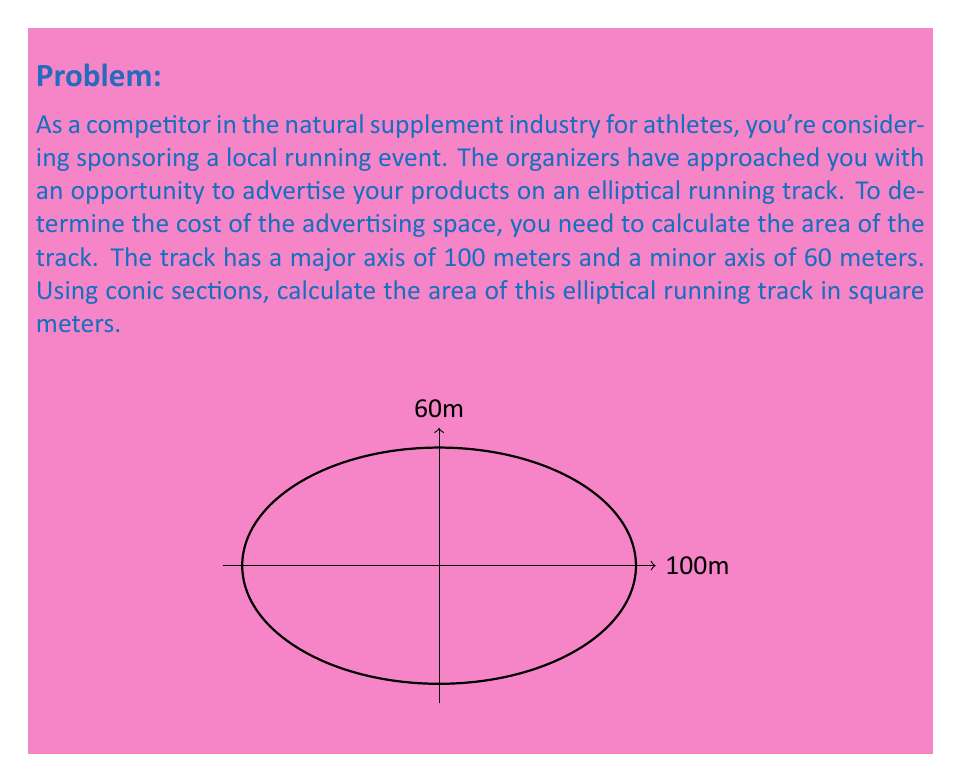Can you solve this math problem? To calculate the area of an elliptical running track using conic sections, we'll follow these steps:

1) The general formula for the area of an ellipse is:

   $$A = \pi ab$$

   where $a$ is the length of the semi-major axis and $b$ is the length of the semi-minor axis.

2) In this case, we're given the full length of the major and minor axes:
   - Major axis = 100 meters
   - Minor axis = 60 meters

3) We need to halve these values to get the semi-major and semi-minor axes:
   $$a = \frac{100}{2} = 50\text{ meters}$$
   $$b = \frac{60}{2} = 30\text{ meters}$$

4) Now we can substitute these values into our area formula:

   $$A = \pi (50)(30)$$

5) Simplify:
   $$A = 1500\pi\text{ square meters}$$

6) If we need a decimal approximation, we can calculate:
   $$A \approx 4712.39\text{ square meters}$$
Answer: $1500\pi\text{ m}^2$ or approximately $4712.39\text{ m}^2$ 